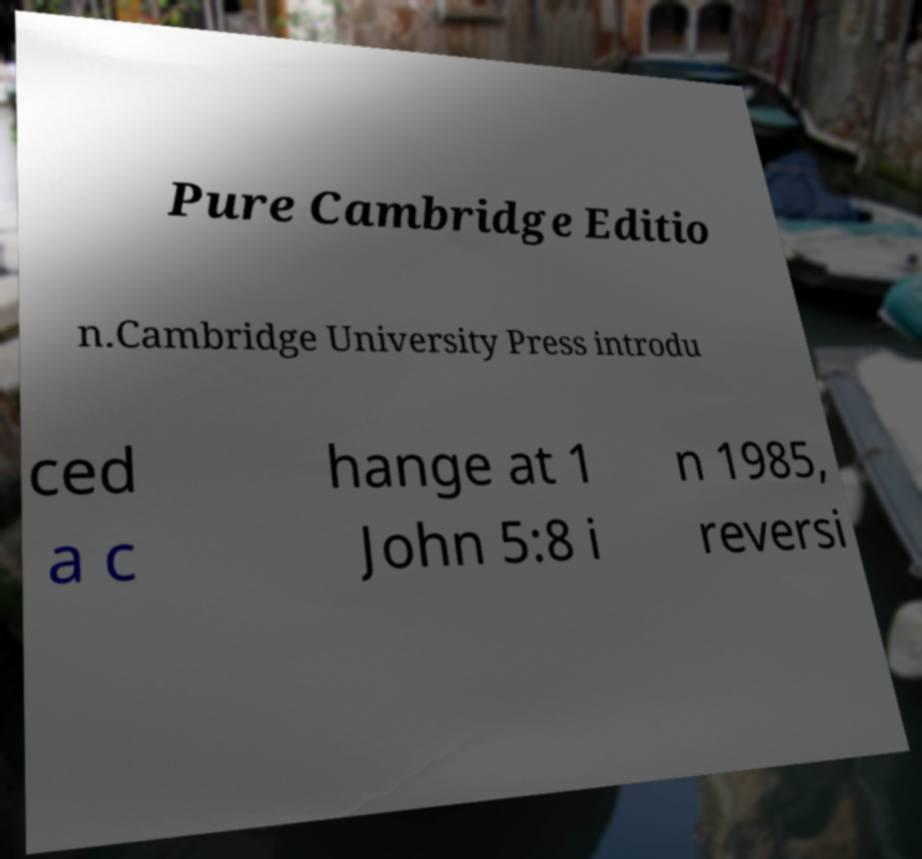Can you read and provide the text displayed in the image?This photo seems to have some interesting text. Can you extract and type it out for me? Pure Cambridge Editio n.Cambridge University Press introdu ced a c hange at 1 John 5:8 i n 1985, reversi 